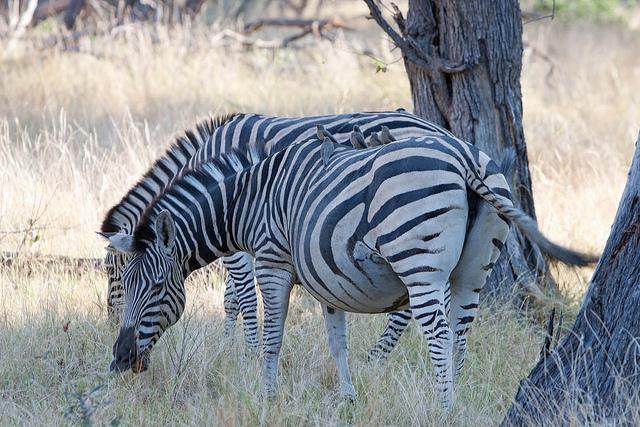How many zebras are in the photo?
Give a very brief answer. 2. How many people are in this room?
Give a very brief answer. 0. 